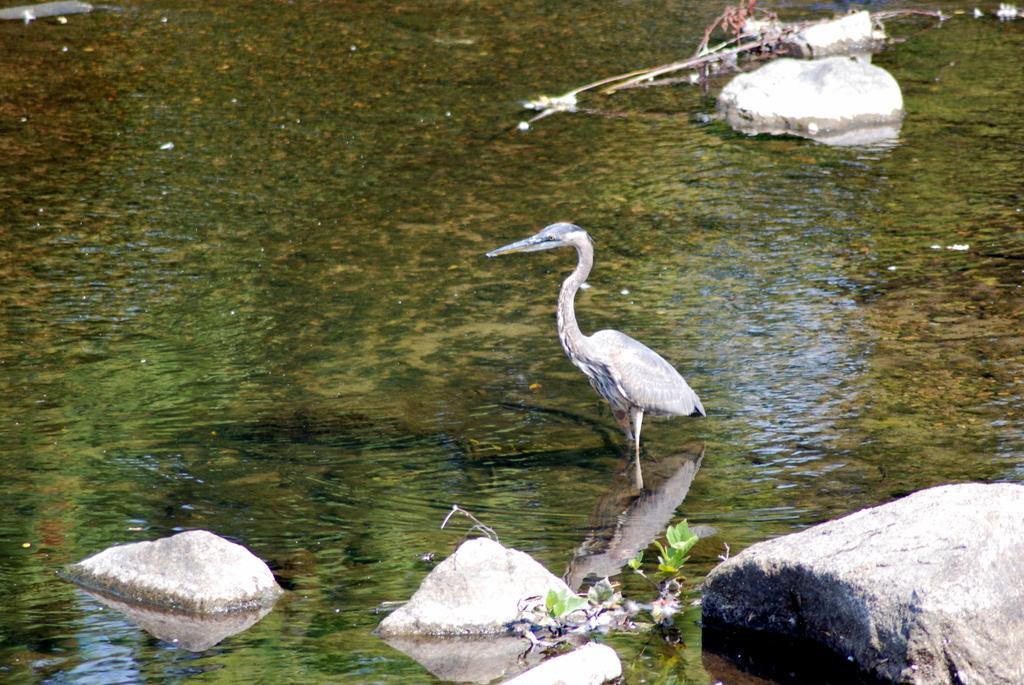How would you summarize this image in a sentence or two? In this image there is water, there is a bird, there are plants, there are rocks in the water, there is an object towards the top of the image. 